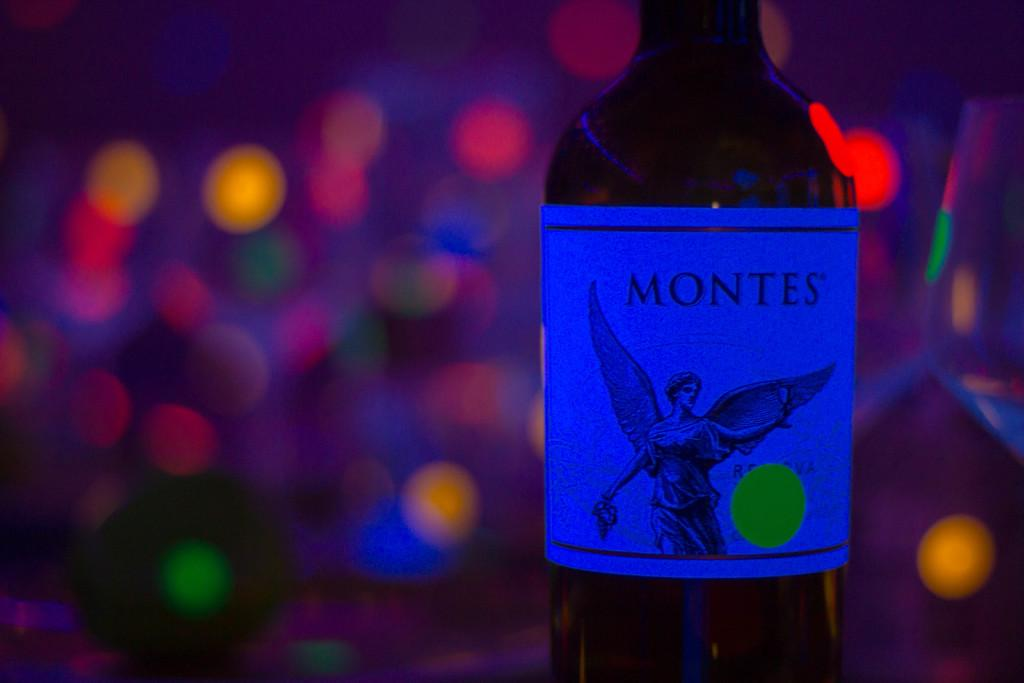<image>
Render a clear and concise summary of the photo. A bottle of Montes wine sits in front of a blurry background of lights. 